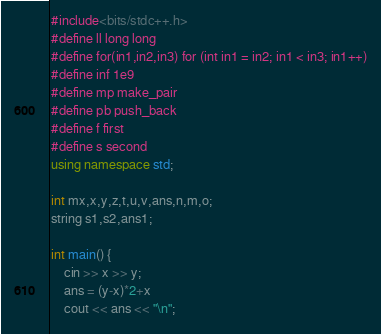<code> <loc_0><loc_0><loc_500><loc_500><_C++_>#include<bits/stdc++.h>
#define ll long long
#define for(in1,in2,in3) for (int in1 = in2; in1 < in3; in1++)
#define inf 1e9
#define mp make_pair
#define pb push_back
#define f first
#define s second
using namespace std;

int mx,x,y,z,t,u,v,ans,n,m,o;
string s1,s2,ans1;

int main() {
	cin >> x >> y;
	ans = (y-x)*2+x
	cout << ans << "\n";</code> 